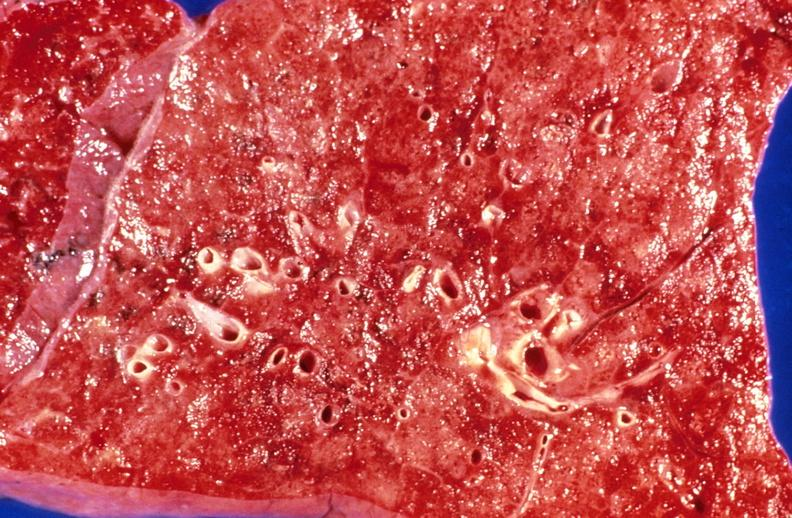does this image show aspiration pneumonia, acute alcoholic?
Answer the question using a single word or phrase. Yes 